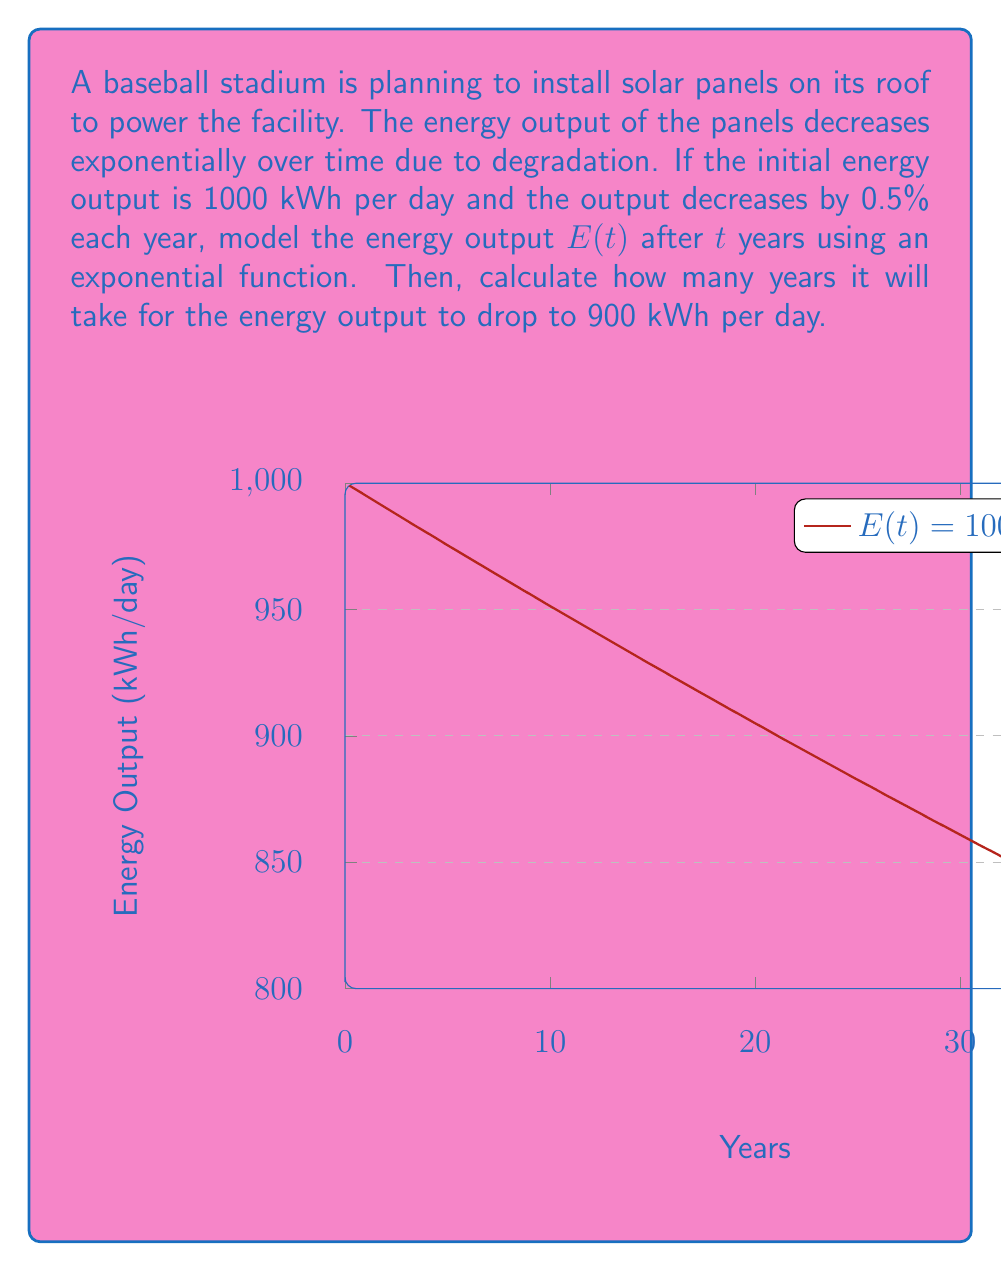What is the answer to this math problem? Let's approach this step-by-step:

1) The general form of an exponential decay function is:
   $$E(t) = E_0 \cdot e^{-kt}$$
   where $E_0$ is the initial value, $k$ is the decay constant, and $t$ is time.

2) We know $E_0 = 1000$ kWh/day.

3) To find $k$, we use the fact that the output decreases by 0.5% each year:
   $$(1 - 0.005) = e^{-k}$$
   $$\ln(0.995) = -k$$
   $$k = -\ln(0.995) \approx 0.005$$

4) Therefore, our model is:
   $$E(t) = 1000 \cdot e^{-0.005t}$$

5) To find when the output drops to 900 kWh/day, we solve:
   $$900 = 1000 \cdot e^{-0.005t}$$

6) Dividing both sides by 1000:
   $$0.9 = e^{-0.005t}$$

7) Taking the natural log of both sides:
   $$\ln(0.9) = -0.005t$$

8) Solving for $t$:
   $$t = \frac{\ln(0.9)}{-0.005} \approx 21.08$$

Therefore, it will take approximately 21.08 years for the energy output to drop to 900 kWh per day.
Answer: $E(t) = 1000e^{-0.005t}$; 21.08 years 